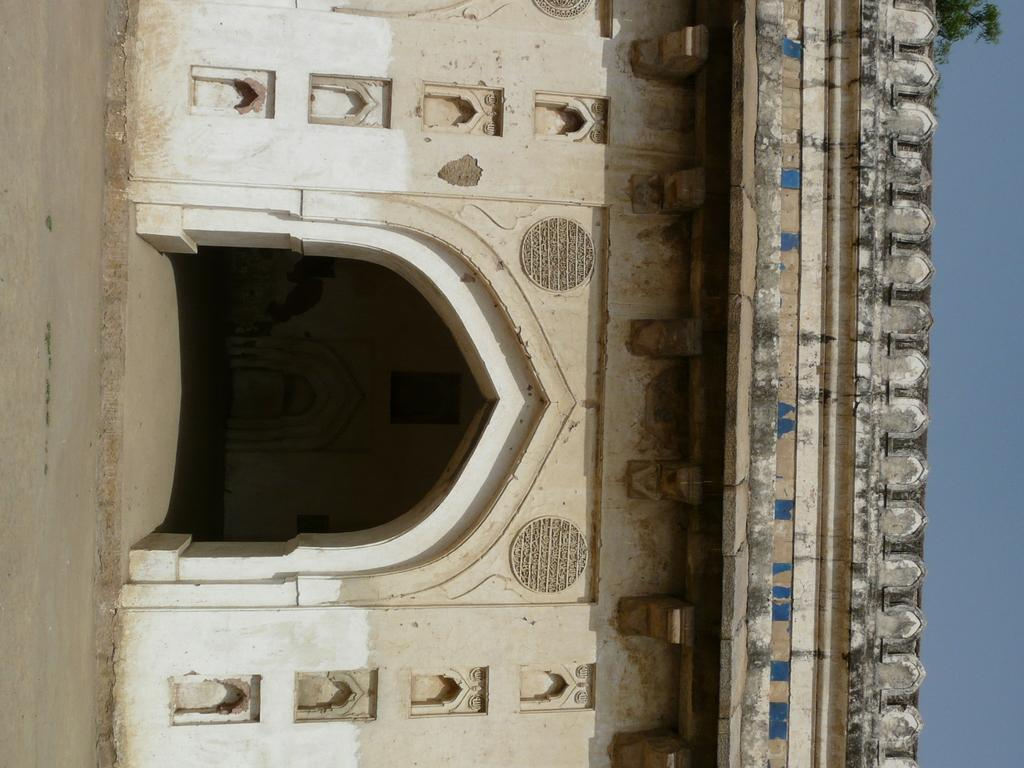What type of surface can be seen in the image? There is ground visible in the image. What structure is present in the image? There is a building in the image. What colors are used on the building? The building is cream, blue, black, and white in color. What can be seen in the background of the image? There is a tree and the sky visible in the background of the image. What is the rate of the oven's temperature in the image? There is no oven present in the image, so it is not possible to determine the rate of its temperature. 